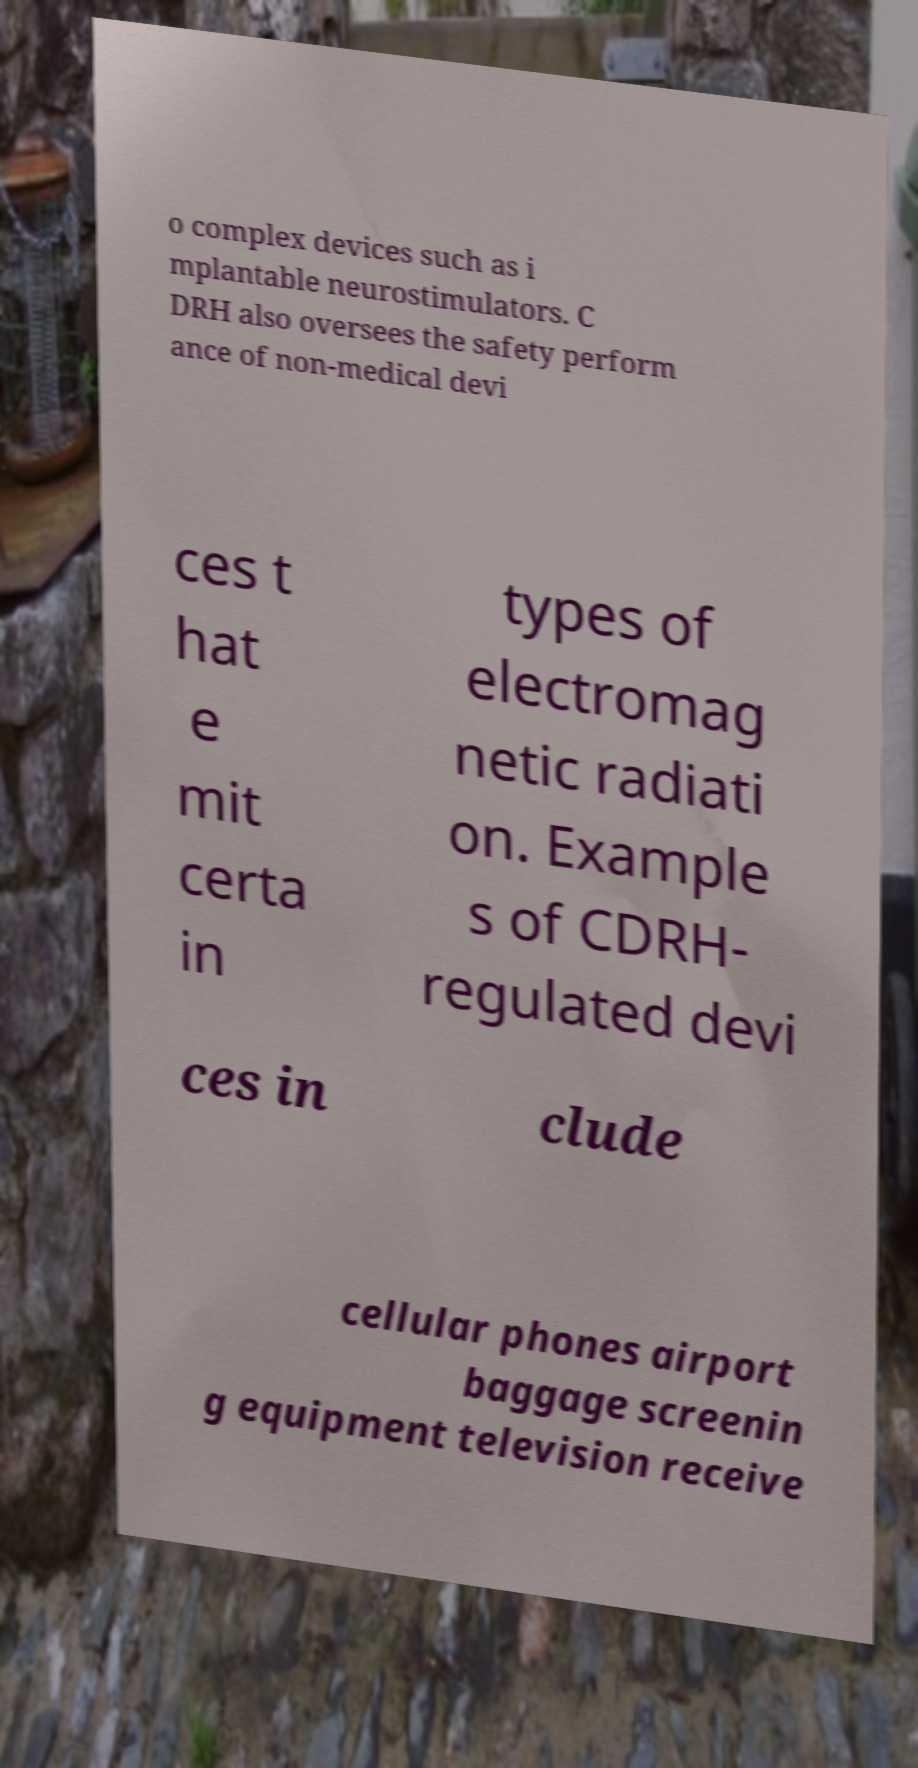Please read and relay the text visible in this image. What does it say? o complex devices such as i mplantable neurostimulators. C DRH also oversees the safety perform ance of non-medical devi ces t hat e mit certa in types of electromag netic radiati on. Example s of CDRH- regulated devi ces in clude cellular phones airport baggage screenin g equipment television receive 